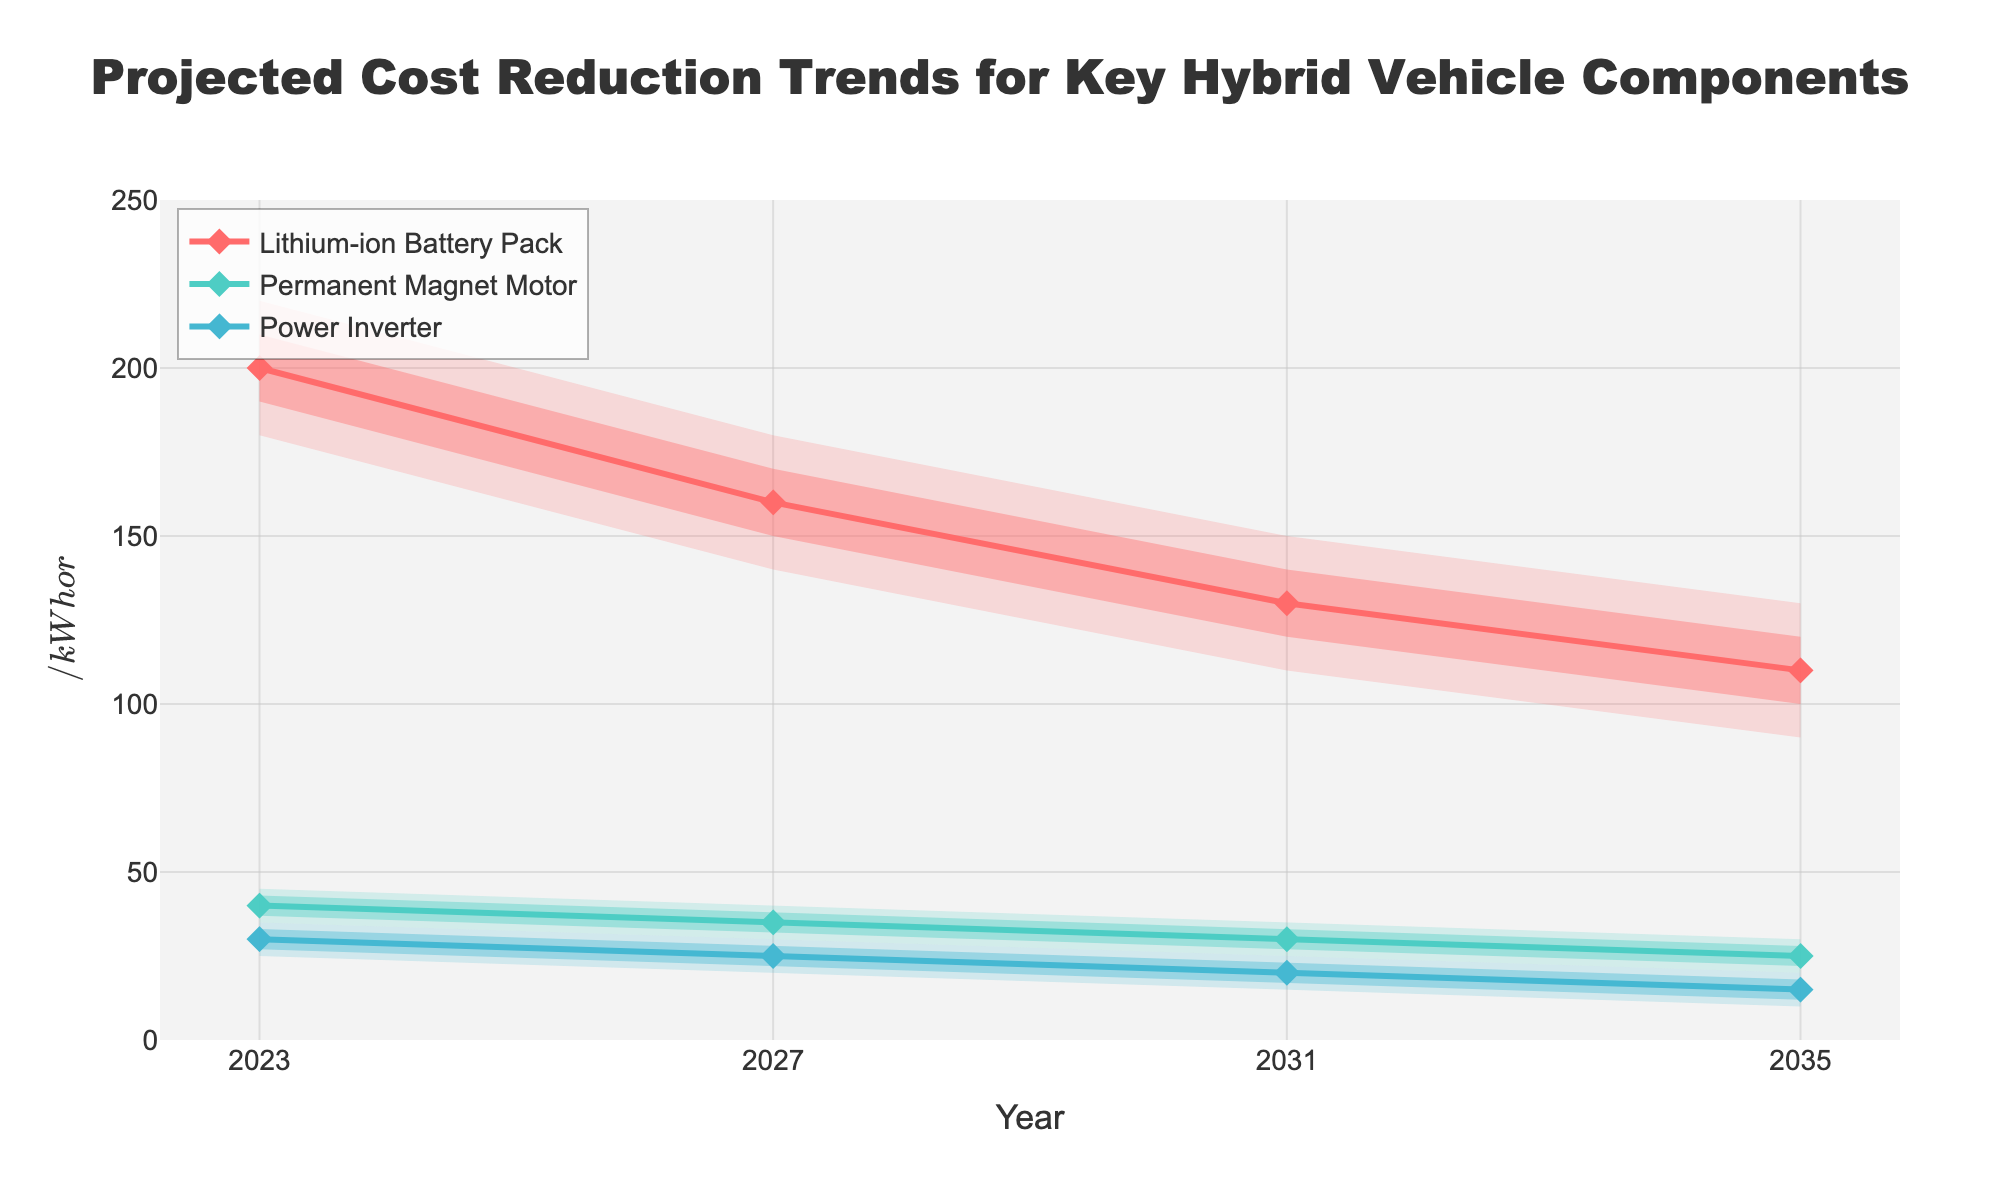What is the title of the figure? The title is typically found at the top of the figure and summarizes what the chart is about.
Answer: Projected Cost Reduction Trends for Key Hybrid Vehicle Components What components are tracked in the figure? The components are visually represented by different colored lines on the chart. By examining these, you can identify the categories.
Answer: Lithium-ion Battery Pack, Permanent Magnet Motor, Power Inverter In which year is the projected cost of the lithium-ion battery pack the lowest? By examining the 'Mid' values for the lithium-ion battery pack across the years, we can determine the year with the lowest cost.
Answer: 2035 What is the median projected cost of the power inverter in 2027? The median cost can be identified as the 'Mid' value for the year 2027 under the Power Inverter category.
Answer: 25 Between 2023 and 2035, by how much does the low-end projected cost for the permanent magnet motor decrease? Subtract the low-end cost in 2035 from the low-end cost in 2023 for the permanent magnet motor.
Answer: 15 (35-20) Which component shows the largest projected cost reduction from 2023 to 2035? Calculate the difference between the 2023 and 2035 ‘Mid’ projections for each component and compare these values.
Answer: Lithium-ion Battery Pack Are the cost ranges projected to be wider or narrower in 2035 compared to 2023 for power inverters? Compare the difference between 'High' and 'Low' values for power inverters in 2023 and 2035.
Answer: Narrower What is the cost range for the permanent magnet motor in 2031? The cost range is determined by subtracting the low-end value from the high-end value for the year 2031 under the Permanent Magnet Motor category.
Answer: 10 (35-25) Which component has the least variance in projected costs in 2023? The variance can be approximated by comparing the width of the fan (difference between high and low values) for each component in 2023.
Answer: Power Inverter 